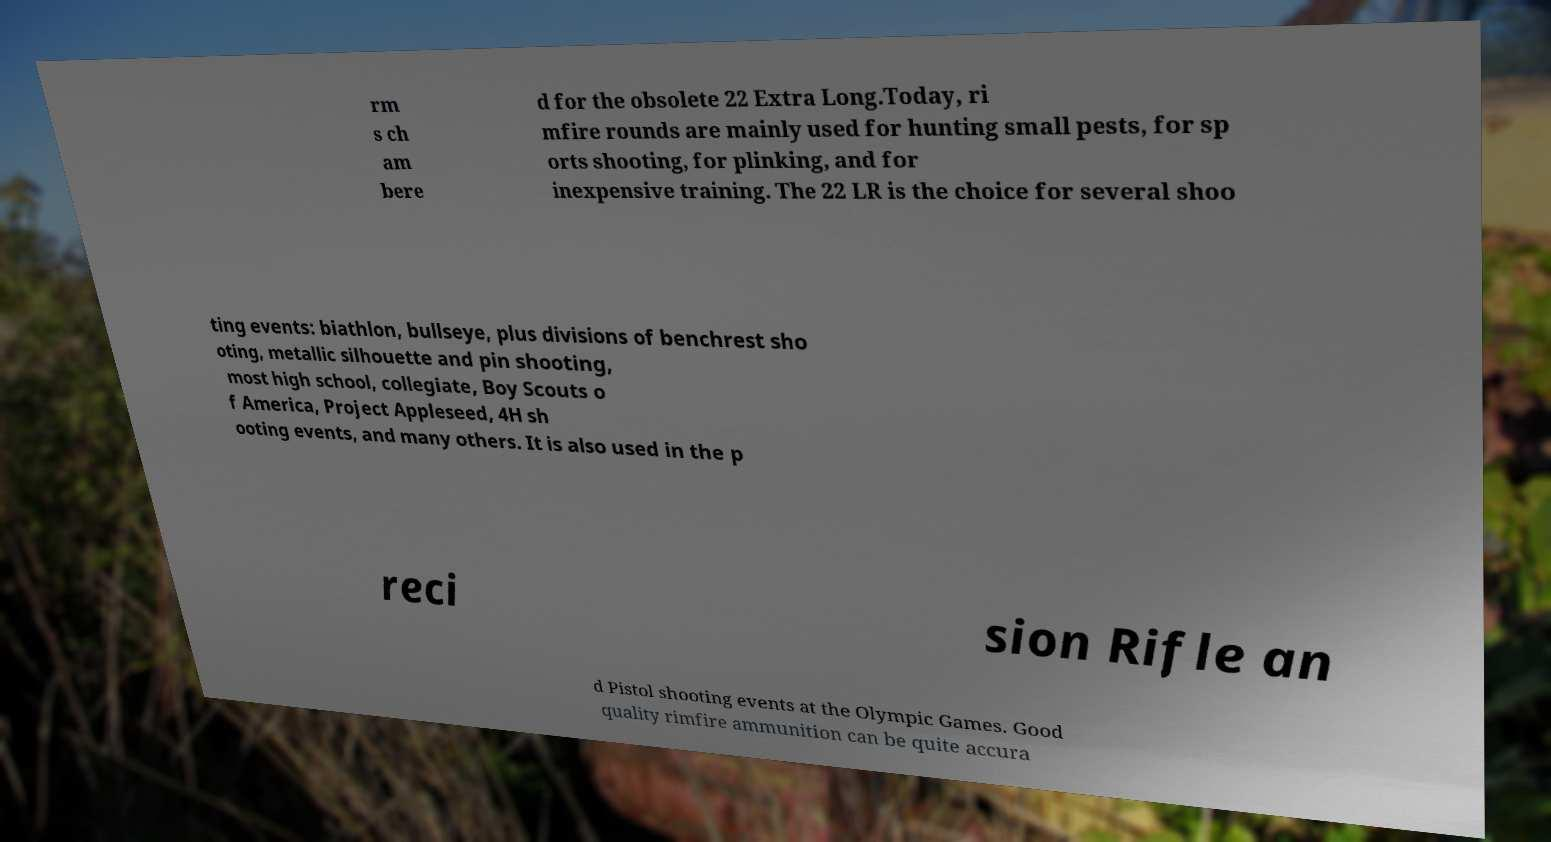I need the written content from this picture converted into text. Can you do that? rm s ch am bere d for the obsolete 22 Extra Long.Today, ri mfire rounds are mainly used for hunting small pests, for sp orts shooting, for plinking, and for inexpensive training. The 22 LR is the choice for several shoo ting events: biathlon, bullseye, plus divisions of benchrest sho oting, metallic silhouette and pin shooting, most high school, collegiate, Boy Scouts o f America, Project Appleseed, 4H sh ooting events, and many others. It is also used in the p reci sion Rifle an d Pistol shooting events at the Olympic Games. Good quality rimfire ammunition can be quite accura 